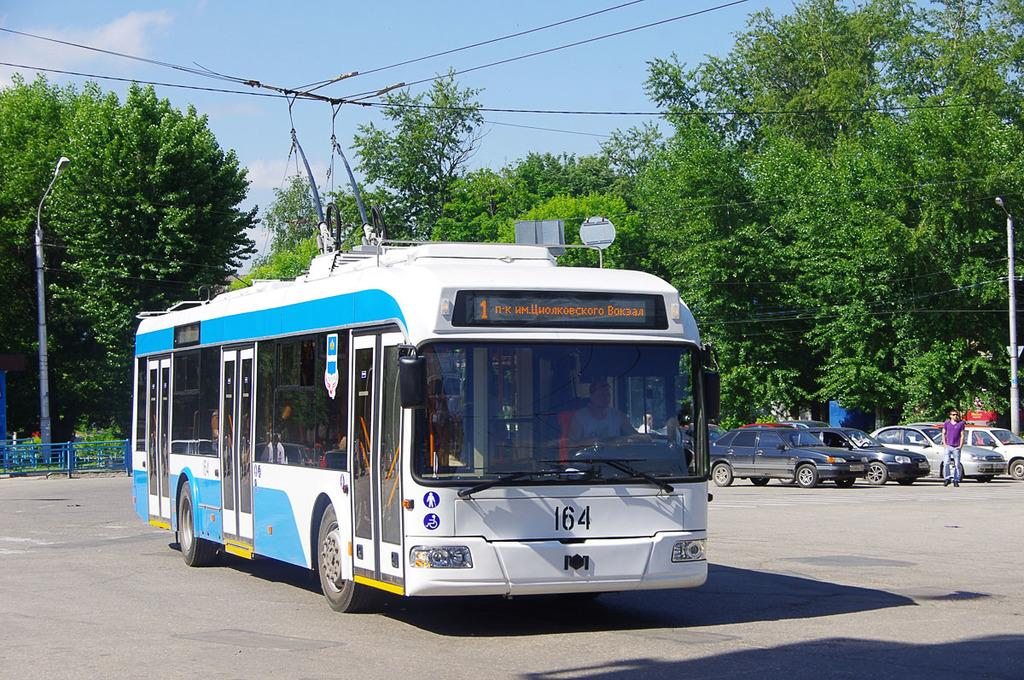What type of vehicle is the main subject in the image? There is a bus in the image. Are there any other vehicles visible in the image? Yes, there are cars in the image. What is the person in the image doing? There is a person walking on the road in the image. What structures can be seen in the image? There are poles and a fence in the image. What type of vegetation is present in the image? There are trees in the image. What can be seen in the background of the image? The sky is visible in the background of the image, and clouds are present in the sky. Where is the can of coal stored in the image? There is no can of coal present in the image. How old is the baby in the image? There is no baby present in the image. 